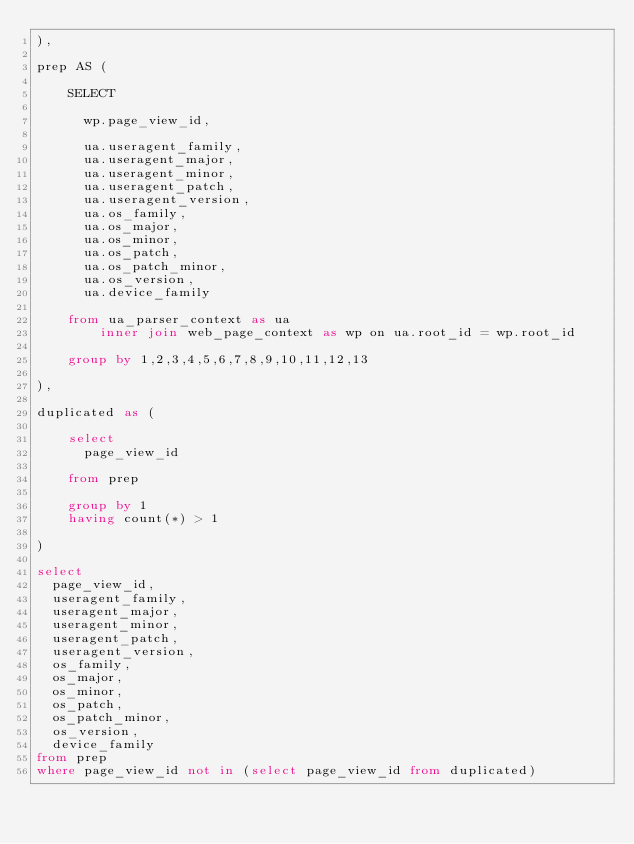Convert code to text. <code><loc_0><loc_0><loc_500><loc_500><_SQL_>),

prep AS (

    SELECT

      wp.page_view_id,

      ua.useragent_family,
      ua.useragent_major,
      ua.useragent_minor,
      ua.useragent_patch,
      ua.useragent_version,
      ua.os_family,
      ua.os_major,
      ua.os_minor,
      ua.os_patch,
      ua.os_patch_minor,
      ua.os_version,
      ua.device_family

    from ua_parser_context as ua
        inner join web_page_context as wp on ua.root_id = wp.root_id

    group by 1,2,3,4,5,6,7,8,9,10,11,12,13

),

duplicated as (

    select
      page_view_id

    from prep

    group by 1
    having count(*) > 1

)

select
  page_view_id,
  useragent_family,
  useragent_major,
  useragent_minor,
  useragent_patch,
  useragent_version,
  os_family,
  os_major,
  os_minor,
  os_patch,
  os_patch_minor,
  os_version,
  device_family
from prep
where page_view_id not in (select page_view_id from duplicated)
</code> 